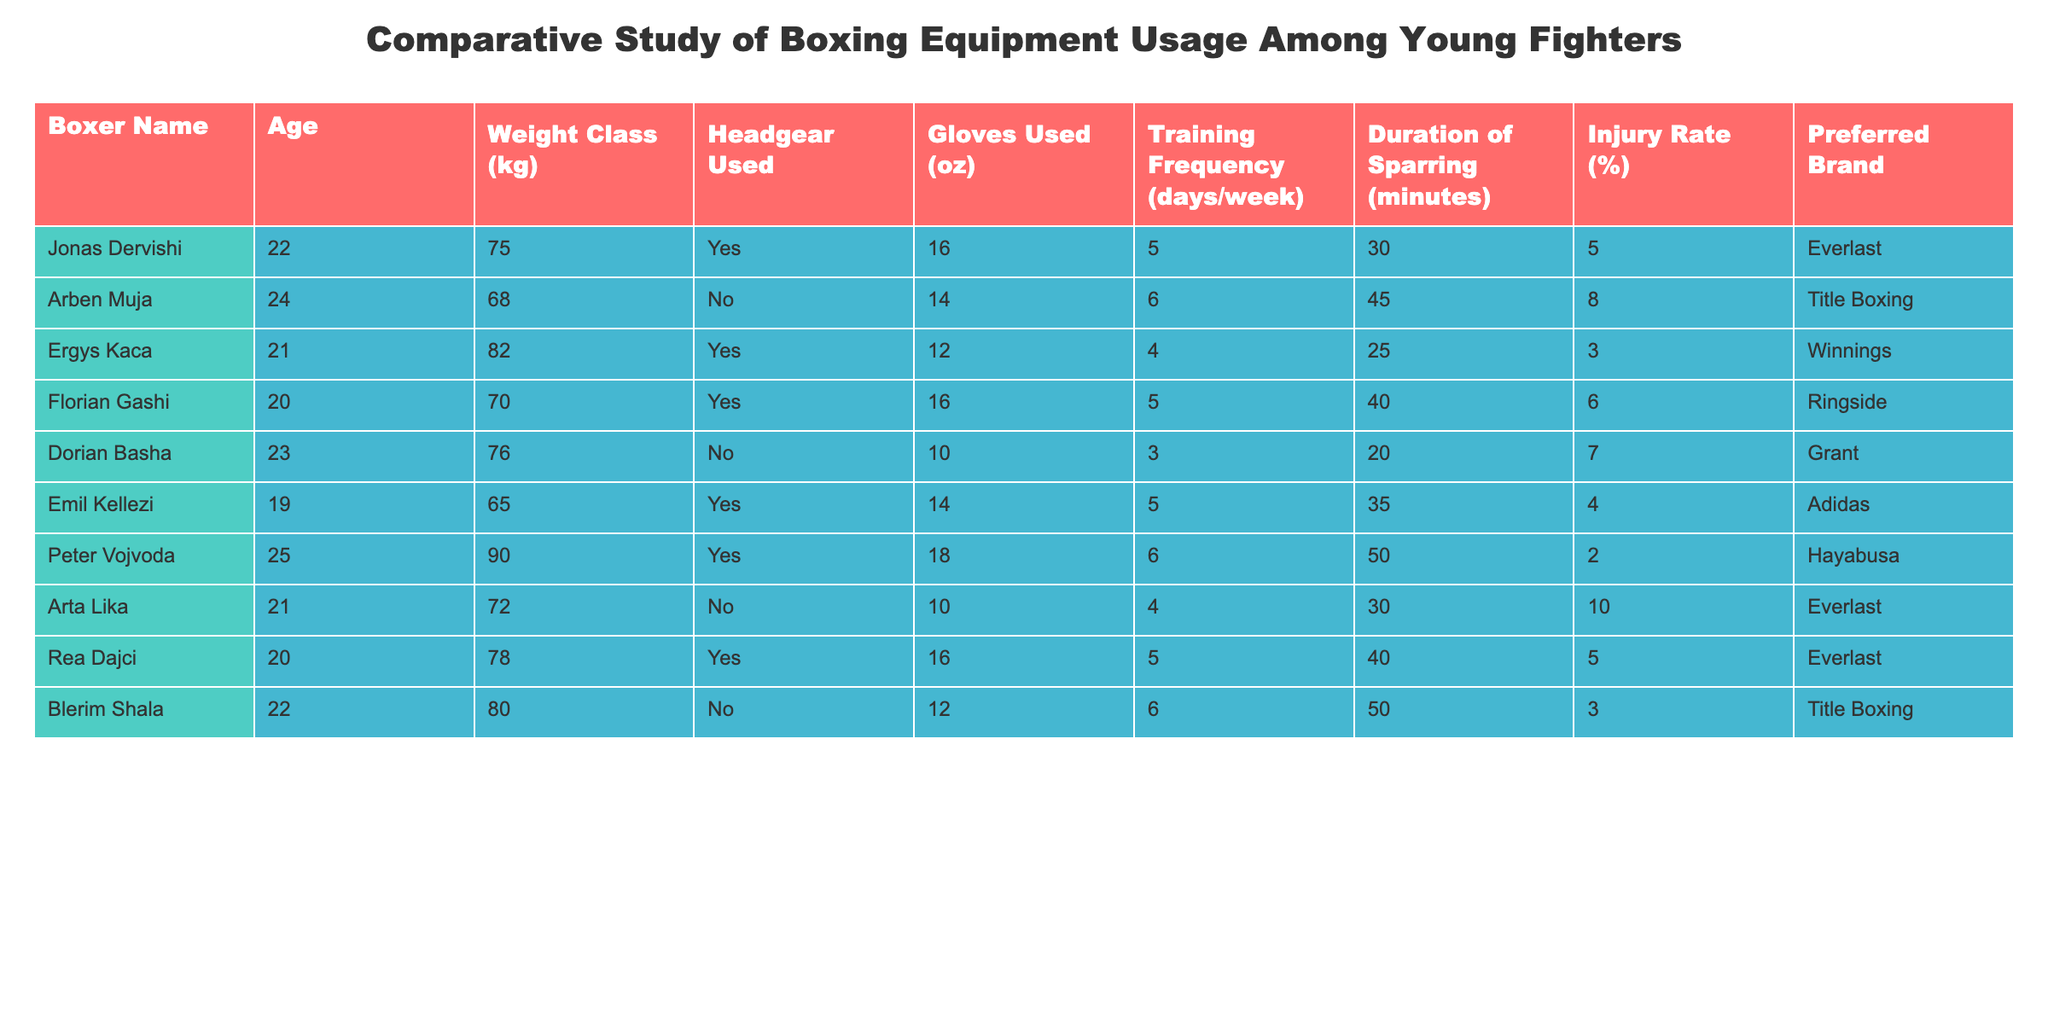What is the injury rate of Emil Kellezi? Emil Kellezi's injury rate is listed directly under the "Injury Rate (%)" column, which shows 4% for him.
Answer: 4% How many boxers used headgear in the study? By scanning the "Headgear Used" column, we see that Jonas Dervishi, Ergys Kaca, Florian Gashi, Emil Kellezi, Rea Dajci all used headgear, totaling 5 users.
Answer: 5 What is the average glove size used by boxers who reported higher injury rates (above 5%)? First, identify boxers with injury rates above 5%, which are Arben Muja, Dorian Basha, and Arta Lika. Their glove sizes are 14 oz, 10 oz, and 10 oz respectively. The average is calculated as (14 + 10 + 10) / 3 = 11.33 oz.
Answer: 11.33 oz Is the usage of gloves above 12 oz linked to higher injury rates? Looking at boxers using gloves above 12 oz (Jonas Dervishi, Peter Vojvoda, and Florian Gashi), the injury rates are 5%, 2%, and 6%, respectively. This shows that higher glove sizes do not consistently link to higher injury rates.
Answer: No What is the preferred brand of the boxer with the lowest injury rate? Scanning the injury rates, Peter Vojvoda has the lowest injury rate at 2%. His preferred brand is Hayabusa.
Answer: Hayabusa How many boxers spar for more than 40 minutes? Looking at the "Duration of Sparring (minutes)" column, boxers who spar for more than 40 minutes are Arben Muja, Peter Vojvoda, and Rea Dajci, totaling 3 boxers.
Answer: 3 Which weight class has the highest average injury rate? To calculate this, group the boxers by weight class and sum their injury rates: 75 kg (5%), 68 kg (8%), 82 kg (3%), 70 kg (6%), 76 kg (7%), 65 kg (4%), 90 kg (2%), 72 kg (10%), and 78 kg (5%). Total injury rates: 5 + 8 + 3 + 6 + 7 + 4 + 2 + 10 + 5 = 50; average = 50 / 9 = 5.56%. Weight class 72 kg has the highest rate at 10%.
Answer: 72 kg What is the correlation between training frequency and the injury rate in this study? We can observe trends by comparing the "Training Frequency (days/week)" and "Injury Rate (%)" columns together. Higher training (6 days) usually appears with upper injury rates like Arben Muja (8%), or Blerim Shala (3%) with 6 days too, but it varies. No direct correlation can be concluded without a solid statistical analysis.
Answer: No clear correlation Does every boxer use gloves that are 14 oz or higher? Scanning the "Gloves Used (oz)" column shows that both Dorian Basha and Arta Lika use gloves less than 14 oz (10 oz).
Answer: No 